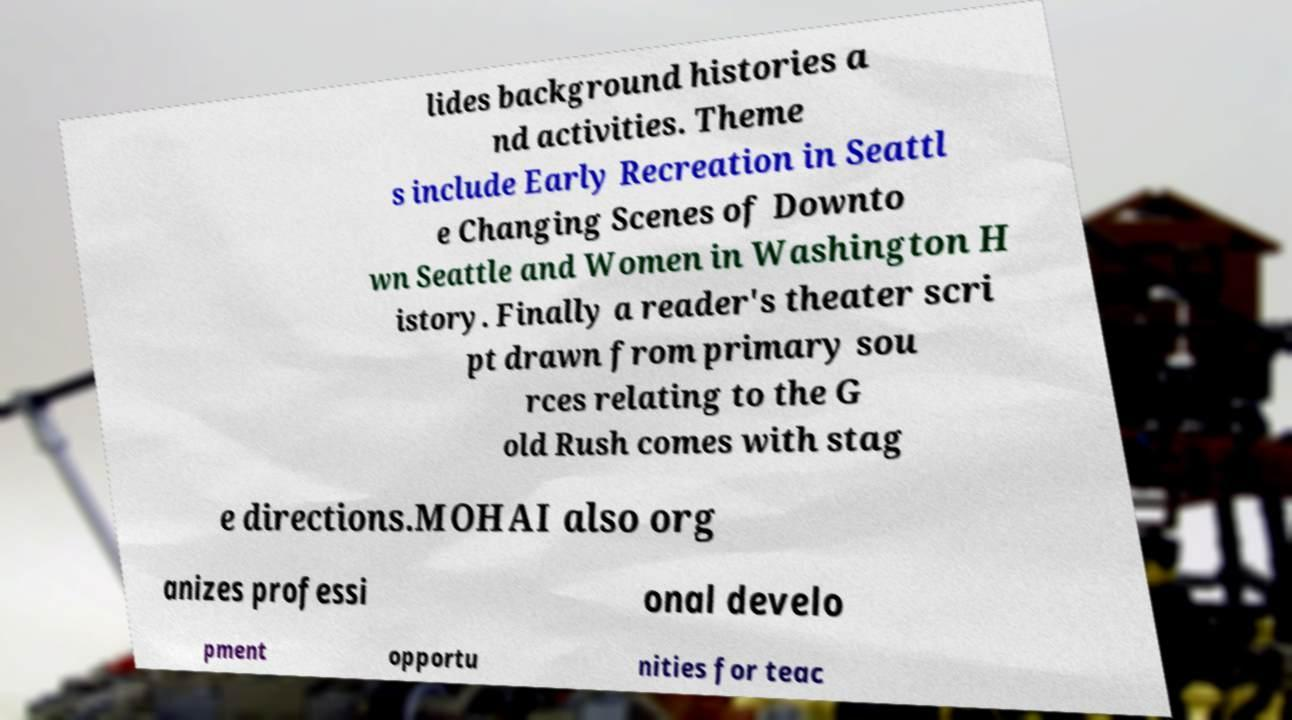There's text embedded in this image that I need extracted. Can you transcribe it verbatim? lides background histories a nd activities. Theme s include Early Recreation in Seattl e Changing Scenes of Downto wn Seattle and Women in Washington H istory. Finally a reader's theater scri pt drawn from primary sou rces relating to the G old Rush comes with stag e directions.MOHAI also org anizes professi onal develo pment opportu nities for teac 